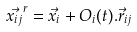Convert formula to latex. <formula><loc_0><loc_0><loc_500><loc_500>\vec { x _ { i j } } ^ { r } = \vec { x } _ { i } + O _ { i } ( t ) . \vec { r } _ { i j }</formula> 